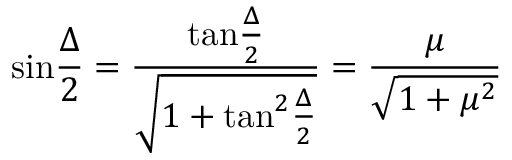<formula> <loc_0><loc_0><loc_500><loc_500>\sin { \frac { \Delta } { 2 } } = { \frac { t a n { \frac { \Delta } { 2 } } } { \sqrt { 1 + t a n ^ { 2 } { \frac { \Delta } { 2 } } } } } = { \frac { \mu } { \sqrt { 1 + \mu ^ { 2 } } } }</formula> 